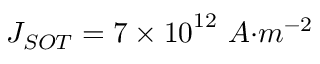<formula> <loc_0><loc_0><loc_500><loc_500>J _ { S O T } = 7 \times { 1 0 } ^ { 1 2 } \ { A { m } ^ { - 2 }</formula> 